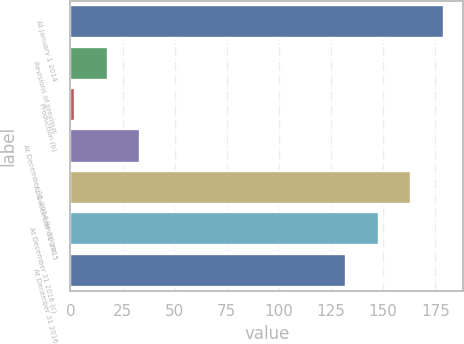Convert chart. <chart><loc_0><loc_0><loc_500><loc_500><bar_chart><fcel>At January 1 2014<fcel>Revisions of previous<fcel>Production (b)<fcel>At December 31 2014 Revisions<fcel>At December 31 2015<fcel>At December 31 2016 (c)<fcel>At December 31 2016<nl><fcel>179.4<fcel>17.8<fcel>2<fcel>33.6<fcel>163.6<fcel>147.8<fcel>132<nl></chart> 